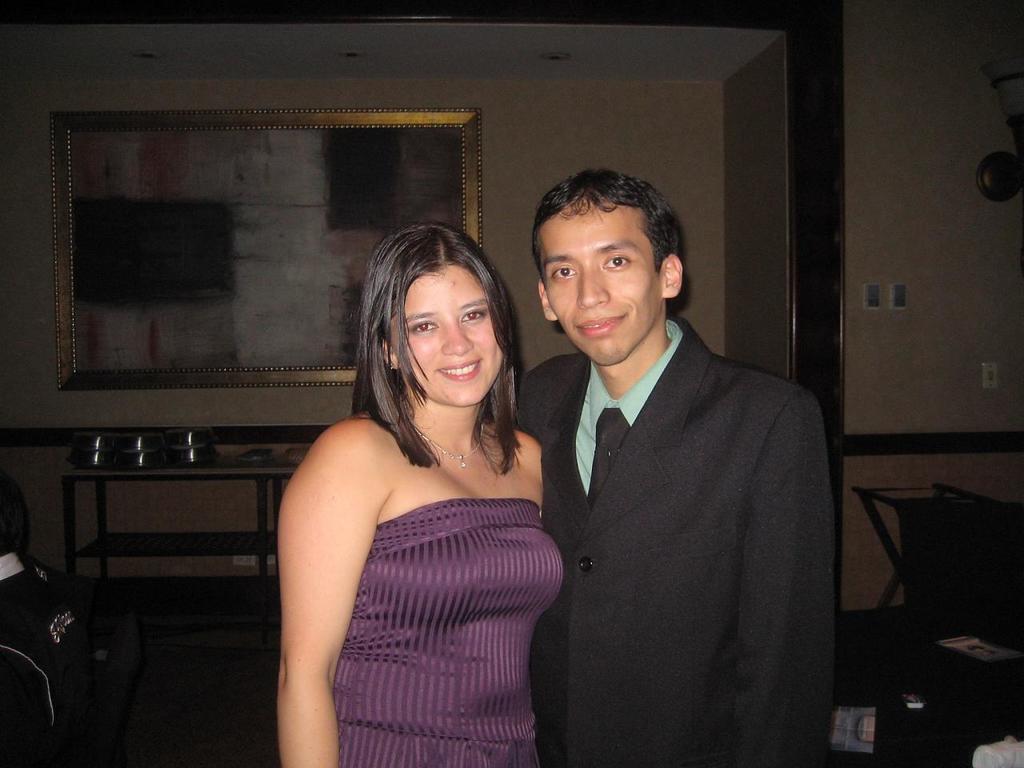Could you give a brief overview of what you see in this image? In this image, we can see a couple standing, in the background we can see a table and we can see a wall. 